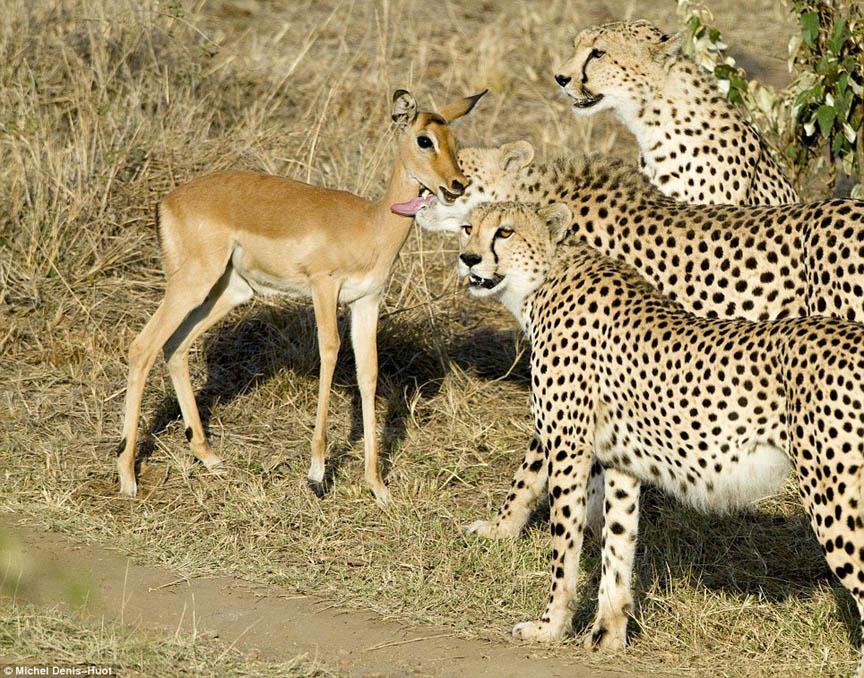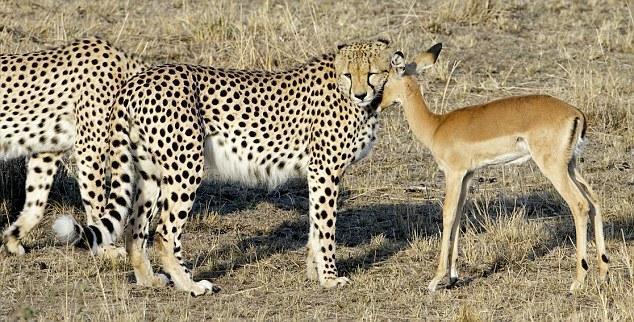The first image is the image on the left, the second image is the image on the right. Analyze the images presented: Is the assertion "In one of the images there is a single leopard running." valid? Answer yes or no. No. The first image is the image on the left, the second image is the image on the right. Analyze the images presented: Is the assertion "There are three total cheetahs." valid? Answer yes or no. No. 